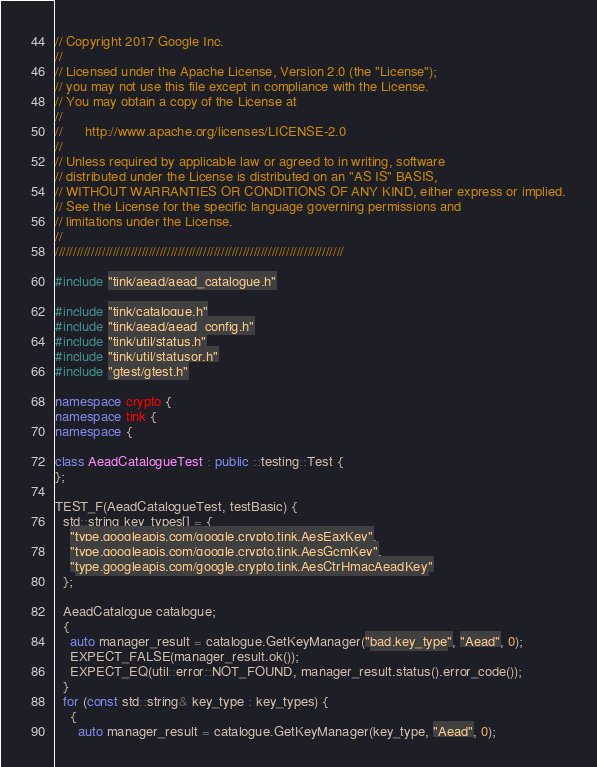Convert code to text. <code><loc_0><loc_0><loc_500><loc_500><_C++_>// Copyright 2017 Google Inc.
//
// Licensed under the Apache License, Version 2.0 (the "License");
// you may not use this file except in compliance with the License.
// You may obtain a copy of the License at
//
//      http://www.apache.org/licenses/LICENSE-2.0
//
// Unless required by applicable law or agreed to in writing, software
// distributed under the License is distributed on an "AS IS" BASIS,
// WITHOUT WARRANTIES OR CONDITIONS OF ANY KIND, either express or implied.
// See the License for the specific language governing permissions and
// limitations under the License.
//
////////////////////////////////////////////////////////////////////////////////

#include "tink/aead/aead_catalogue.h"

#include "tink/catalogue.h"
#include "tink/aead/aead_config.h"
#include "tink/util/status.h"
#include "tink/util/statusor.h"
#include "gtest/gtest.h"

namespace crypto {
namespace tink {
namespace {

class AeadCatalogueTest : public ::testing::Test {
};

TEST_F(AeadCatalogueTest, testBasic) {
  std::string key_types[] = {
    "type.googleapis.com/google.crypto.tink.AesEaxKey",
    "type.googleapis.com/google.crypto.tink.AesGcmKey",
    "type.googleapis.com/google.crypto.tink.AesCtrHmacAeadKey"
  };

  AeadCatalogue catalogue;
  {
    auto manager_result = catalogue.GetKeyManager("bad.key_type", "Aead", 0);
    EXPECT_FALSE(manager_result.ok());
    EXPECT_EQ(util::error::NOT_FOUND, manager_result.status().error_code());
  }
  for (const std::string& key_type : key_types) {
    {
      auto manager_result = catalogue.GetKeyManager(key_type, "Aead", 0);</code> 